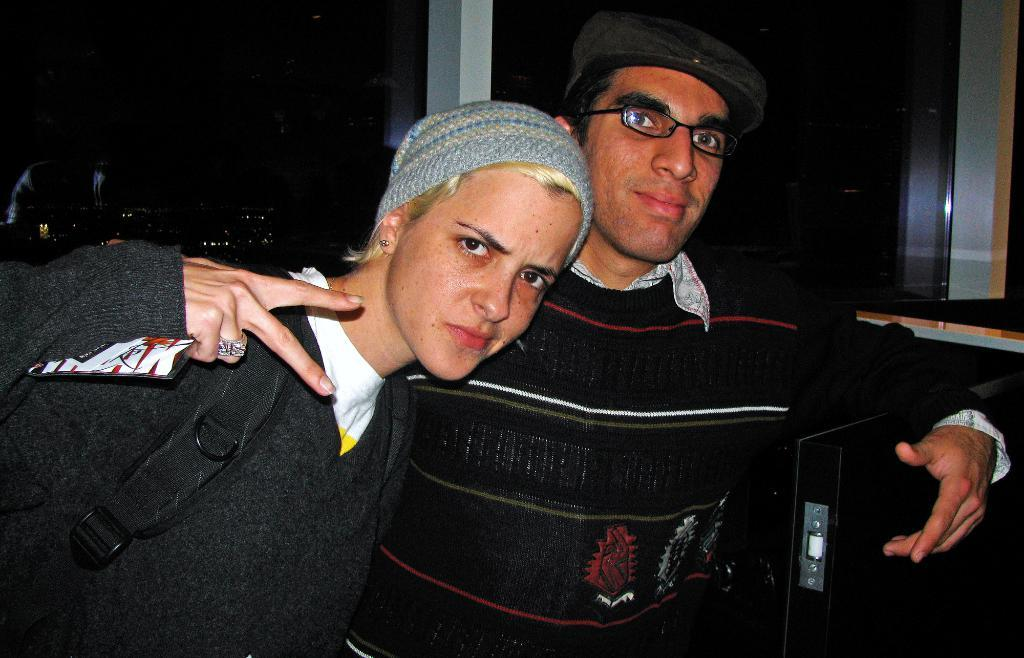How many people are in the image? There are two persons in the image. What is the location of the persons in the image? The persons are in front of a glass window. Can you describe the object in the bottom right of the image? Unfortunately, the provided facts do not give any information about the object in the bottom right of the image. What type of eggnog can be seen in the hands of the persons in the image? There is no eggnog present in the image. How many times do the persons in the image laugh together? The provided facts do not mention laughter or any emotions of the persons in the image. 